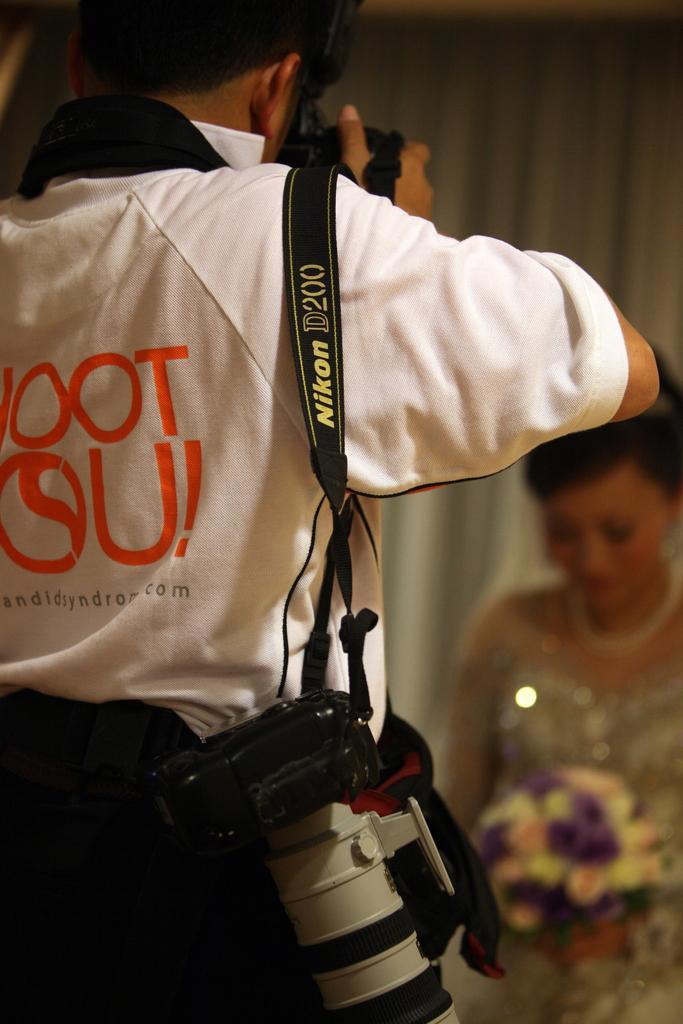Please provide a concise description of this image. In this image we can see a man is standing and taking photograph. He is wearing white color t-shirt and black pant and carrying one camera. In front of him one girl is standing by holding flower bouquet in her hand. 